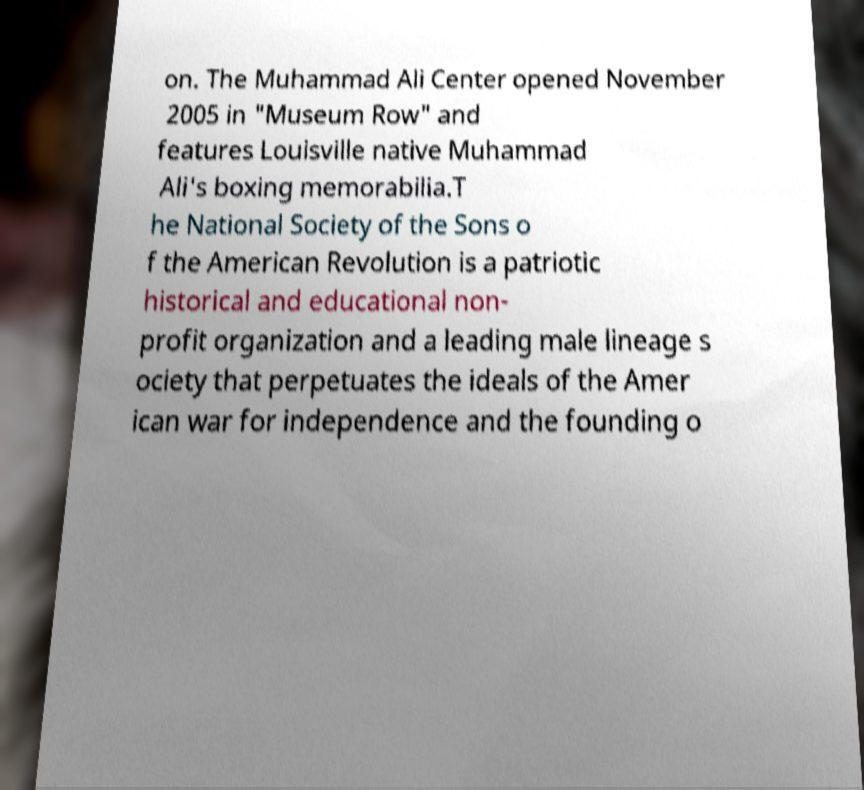Could you extract and type out the text from this image? on. The Muhammad Ali Center opened November 2005 in "Museum Row" and features Louisville native Muhammad Ali's boxing memorabilia.T he National Society of the Sons o f the American Revolution is a patriotic historical and educational non- profit organization and a leading male lineage s ociety that perpetuates the ideals of the Amer ican war for independence and the founding o 